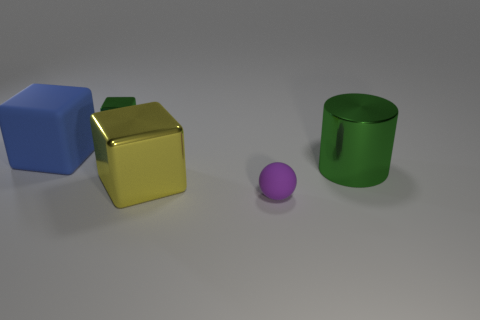Can you tell me more about the shapes and colors seen in the image? Certainly! In the image, there are four distinct shapes: a blue cube, a golden-yellow cube, a small purple sphere, and a green cylinder with a hollow center. The colors are quite vivid and exhibit a high-gloss finish, which enhances their appearance under the neutral lighting present in the scene. The arrangement is simple and evenly spaced, allowing each object's color and form to be easily discernible. 